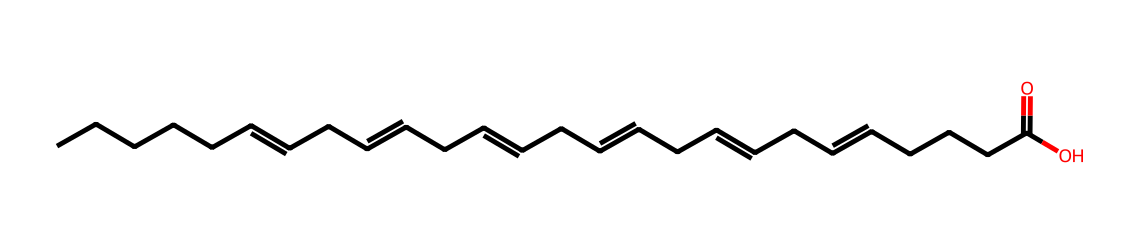What is the molecular formula of docosahexaenoic acid? The molecular formula can be derived from counting the number of carbon (C), hydrogen (H), and oxygen (O) atoms in the SMILES representation. There are 22 carbon atoms, 32 hydrogen atoms, and 2 oxygen atoms, giving a molecular formula of C22H32O2.
Answer: C22H32O2 How many double bonds are present in this molecule? By analyzing the structural representation in the SMILES, we note the presence of multiple "C=C" notations which denote double bonds. Specifically, there are six double bonds present in docosahexaenoic acid's structure.
Answer: 6 What type of compound is docosahexaenoic acid classified as? The presence of a long carbon chain and carboxylic acid functional group indicates that this compound is a fatty acid. Since it consists solely of carbon and hydrogen bonds in the hydrocarbon chain, it is classified as an aliphatic compound.
Answer: fatty acid How many carbon atoms are part of the main hydrocarbon chain? In the molecule, the main chain can be identified by counting the continuous carbon atoms that make up the backbone, not including the carboxylic end. In this structure, there are 22 carbon atoms in total, including the end functional group.
Answer: 22 Is docosahexaenoic acid saturated or unsaturated? The presence of multiple double bonds (indicated by "C=C") in the structure reveals that the molecule cannot be fully saturated with hydrogen atoms. The existence of these double bonds confirms that it is an unsaturated fatty acid.
Answer: unsaturated What functional group does docosahexaenoic acid contain? The molecule ends with "C(=O)O," identifying the presence of a carboxylic acid functional group, which is typical in fatty acids. This functional group features a carbon atom double-bonded to an oxygen and single-bonded to a hydroxyl group.
Answer: carboxylic acid 